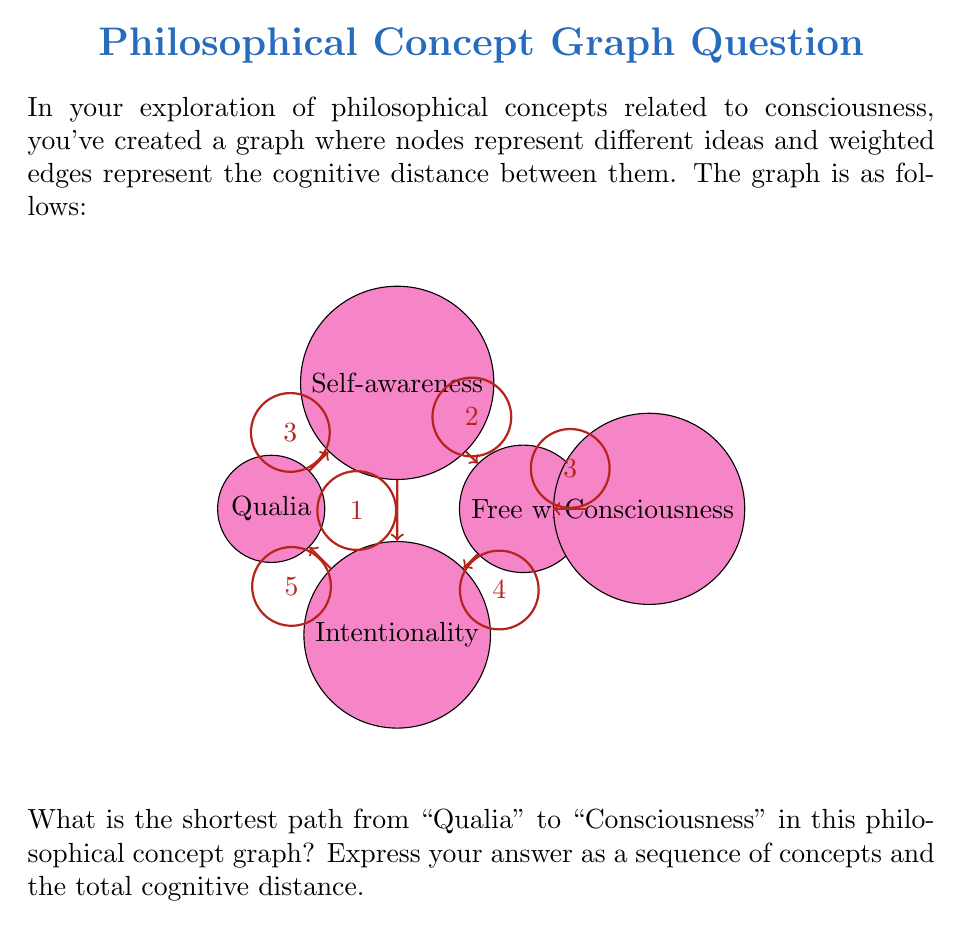Could you help me with this problem? To solve this problem, we can use Dijkstra's algorithm to find the shortest path in a weighted graph. Let's go through the process step-by-step:

1) Initialize:
   - Set distance to Qualia (start) as 0
   - Set distances to all other nodes as infinity
   - Set all nodes as unvisited

2) For the current node (starting with Qualia), consider all unvisited neighbors and calculate their tentative distances.
   - Qualia to Self-awareness: 3
   - Qualia to Intentionality: 5

3) Set Qualia as visited. Self-awareness has the smallest tentative distance (3), so we move to it.

4) From Self-awareness:
   - to Free will: 3 + 2 = 5
   - to Intentionality: 3 + 1 = 4

5) Set Self-awareness as visited. Intentionality now has the smallest tentative distance (4), so we move to it.

6) From Intentionality:
   - to Free will: 4 + 4 = 8 (larger than current, so we don't update)

7) Set Intentionality as visited. Free will has the next smallest tentative distance (5), so we move to it.

8) From Free will:
   - to Consciousness: 5 + 3 = 8

9) We've reached Consciousness, and all nodes have been visited.

The shortest path is: Qualia → Self-awareness → Intentionality → Free will → Consciousness

The total cognitive distance is: 3 + 1 + 4 + 3 = 11
Answer: Qualia → Self-awareness → Intentionality → Free will → Consciousness, distance 11 